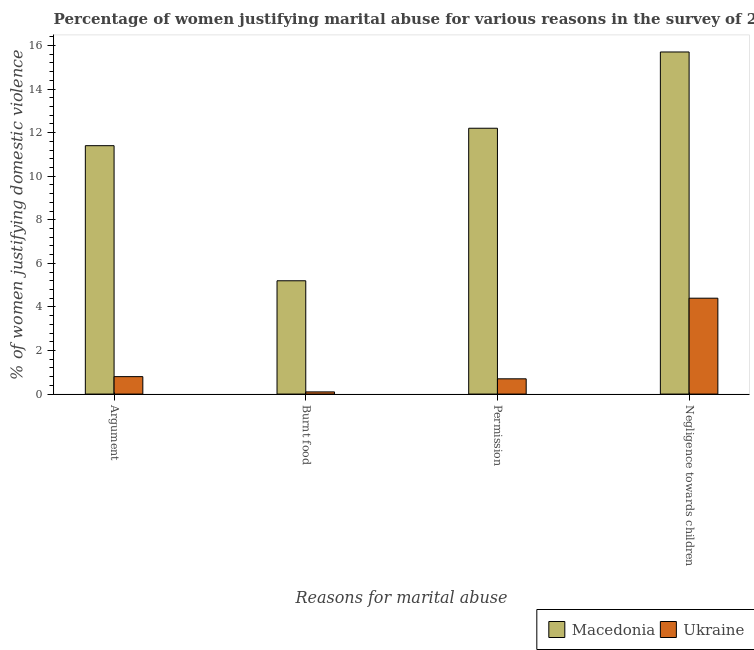How many groups of bars are there?
Offer a terse response. 4. Are the number of bars per tick equal to the number of legend labels?
Ensure brevity in your answer.  Yes. Are the number of bars on each tick of the X-axis equal?
Make the answer very short. Yes. How many bars are there on the 3rd tick from the right?
Provide a short and direct response. 2. What is the label of the 2nd group of bars from the left?
Your answer should be very brief. Burnt food. In which country was the percentage of women justifying abuse for going without permission maximum?
Offer a terse response. Macedonia. In which country was the percentage of women justifying abuse for going without permission minimum?
Ensure brevity in your answer.  Ukraine. What is the total percentage of women justifying abuse in the case of an argument in the graph?
Provide a succinct answer. 12.2. What is the difference between the percentage of women justifying abuse in the case of an argument in Ukraine and that in Macedonia?
Give a very brief answer. -10.6. What is the difference between the percentage of women justifying abuse in the case of an argument in Ukraine and the percentage of women justifying abuse for burning food in Macedonia?
Your response must be concise. -4.4. What is the average percentage of women justifying abuse for going without permission per country?
Your answer should be very brief. 6.45. What is the difference between the percentage of women justifying abuse for going without permission and percentage of women justifying abuse in the case of an argument in Macedonia?
Offer a terse response. 0.8. In how many countries, is the percentage of women justifying abuse in the case of an argument greater than 12 %?
Make the answer very short. 0. What is the ratio of the percentage of women justifying abuse for showing negligence towards children in Ukraine to that in Macedonia?
Keep it short and to the point. 0.28. Is the difference between the percentage of women justifying abuse for burning food in Macedonia and Ukraine greater than the difference between the percentage of women justifying abuse in the case of an argument in Macedonia and Ukraine?
Keep it short and to the point. No. What is the difference between the highest and the second highest percentage of women justifying abuse for burning food?
Make the answer very short. 5.1. What is the difference between the highest and the lowest percentage of women justifying abuse for going without permission?
Your answer should be very brief. 11.5. Is it the case that in every country, the sum of the percentage of women justifying abuse for going without permission and percentage of women justifying abuse in the case of an argument is greater than the sum of percentage of women justifying abuse for showing negligence towards children and percentage of women justifying abuse for burning food?
Make the answer very short. No. What does the 1st bar from the left in Negligence towards children represents?
Provide a succinct answer. Macedonia. What does the 1st bar from the right in Permission represents?
Your answer should be compact. Ukraine. Are the values on the major ticks of Y-axis written in scientific E-notation?
Provide a succinct answer. No. How many legend labels are there?
Make the answer very short. 2. What is the title of the graph?
Offer a very short reply. Percentage of women justifying marital abuse for various reasons in the survey of 2005. Does "Finland" appear as one of the legend labels in the graph?
Give a very brief answer. No. What is the label or title of the X-axis?
Offer a terse response. Reasons for marital abuse. What is the label or title of the Y-axis?
Your response must be concise. % of women justifying domestic violence. What is the % of women justifying domestic violence in Macedonia in Argument?
Offer a terse response. 11.4. What is the % of women justifying domestic violence of Ukraine in Argument?
Your response must be concise. 0.8. What is the % of women justifying domestic violence in Macedonia in Burnt food?
Provide a succinct answer. 5.2. What is the % of women justifying domestic violence of Macedonia in Negligence towards children?
Provide a short and direct response. 15.7. Across all Reasons for marital abuse, what is the maximum % of women justifying domestic violence in Macedonia?
Offer a terse response. 15.7. Across all Reasons for marital abuse, what is the minimum % of women justifying domestic violence of Macedonia?
Your response must be concise. 5.2. Across all Reasons for marital abuse, what is the minimum % of women justifying domestic violence of Ukraine?
Provide a short and direct response. 0.1. What is the total % of women justifying domestic violence of Macedonia in the graph?
Give a very brief answer. 44.5. What is the difference between the % of women justifying domestic violence in Ukraine in Argument and that in Burnt food?
Your response must be concise. 0.7. What is the difference between the % of women justifying domestic violence of Macedonia in Argument and that in Permission?
Keep it short and to the point. -0.8. What is the difference between the % of women justifying domestic violence of Macedonia in Argument and that in Negligence towards children?
Provide a short and direct response. -4.3. What is the difference between the % of women justifying domestic violence in Ukraine in Argument and that in Negligence towards children?
Your response must be concise. -3.6. What is the difference between the % of women justifying domestic violence of Ukraine in Burnt food and that in Permission?
Your answer should be compact. -0.6. What is the difference between the % of women justifying domestic violence of Ukraine in Burnt food and that in Negligence towards children?
Provide a short and direct response. -4.3. What is the difference between the % of women justifying domestic violence of Macedonia in Argument and the % of women justifying domestic violence of Ukraine in Permission?
Give a very brief answer. 10.7. What is the difference between the % of women justifying domestic violence of Macedonia in Permission and the % of women justifying domestic violence of Ukraine in Negligence towards children?
Your answer should be compact. 7.8. What is the average % of women justifying domestic violence of Macedonia per Reasons for marital abuse?
Your answer should be compact. 11.12. What is the difference between the % of women justifying domestic violence in Macedonia and % of women justifying domestic violence in Ukraine in Argument?
Your response must be concise. 10.6. What is the difference between the % of women justifying domestic violence of Macedonia and % of women justifying domestic violence of Ukraine in Permission?
Ensure brevity in your answer.  11.5. What is the difference between the % of women justifying domestic violence in Macedonia and % of women justifying domestic violence in Ukraine in Negligence towards children?
Provide a succinct answer. 11.3. What is the ratio of the % of women justifying domestic violence in Macedonia in Argument to that in Burnt food?
Ensure brevity in your answer.  2.19. What is the ratio of the % of women justifying domestic violence of Ukraine in Argument to that in Burnt food?
Give a very brief answer. 8. What is the ratio of the % of women justifying domestic violence of Macedonia in Argument to that in Permission?
Give a very brief answer. 0.93. What is the ratio of the % of women justifying domestic violence in Ukraine in Argument to that in Permission?
Give a very brief answer. 1.14. What is the ratio of the % of women justifying domestic violence of Macedonia in Argument to that in Negligence towards children?
Your response must be concise. 0.73. What is the ratio of the % of women justifying domestic violence of Ukraine in Argument to that in Negligence towards children?
Your answer should be very brief. 0.18. What is the ratio of the % of women justifying domestic violence in Macedonia in Burnt food to that in Permission?
Your response must be concise. 0.43. What is the ratio of the % of women justifying domestic violence of Ukraine in Burnt food to that in Permission?
Your response must be concise. 0.14. What is the ratio of the % of women justifying domestic violence of Macedonia in Burnt food to that in Negligence towards children?
Keep it short and to the point. 0.33. What is the ratio of the % of women justifying domestic violence of Ukraine in Burnt food to that in Negligence towards children?
Your answer should be very brief. 0.02. What is the ratio of the % of women justifying domestic violence in Macedonia in Permission to that in Negligence towards children?
Offer a very short reply. 0.78. What is the ratio of the % of women justifying domestic violence of Ukraine in Permission to that in Negligence towards children?
Your answer should be compact. 0.16. What is the difference between the highest and the lowest % of women justifying domestic violence in Macedonia?
Make the answer very short. 10.5. What is the difference between the highest and the lowest % of women justifying domestic violence of Ukraine?
Keep it short and to the point. 4.3. 